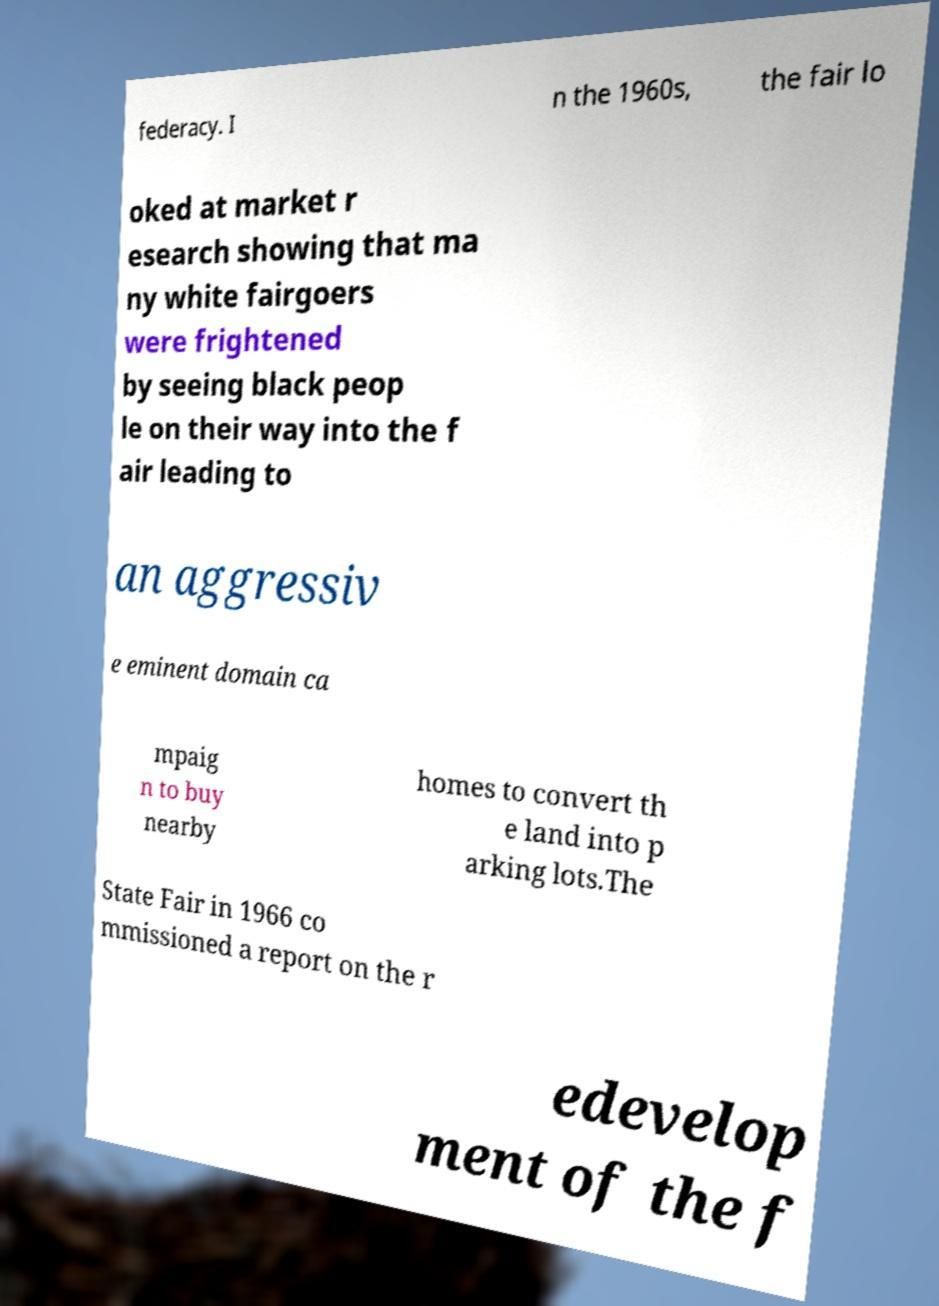I need the written content from this picture converted into text. Can you do that? federacy. I n the 1960s, the fair lo oked at market r esearch showing that ma ny white fairgoers were frightened by seeing black peop le on their way into the f air leading to an aggressiv e eminent domain ca mpaig n to buy nearby homes to convert th e land into p arking lots.The State Fair in 1966 co mmissioned a report on the r edevelop ment of the f 